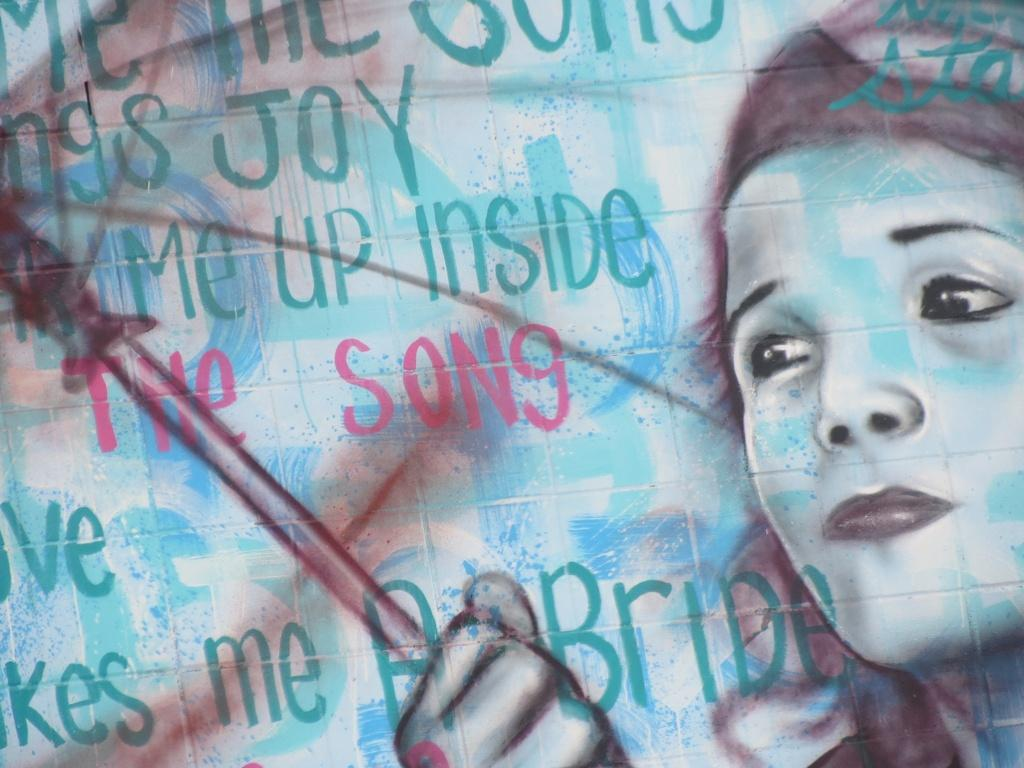What is depicted in the image? There is a sketch of a person in the image. What is the person in the sketch doing? The person is holding an object in the sketch. Where can text be found in the image? There is text on the left side of the image. What type of meat is being served by the secretary in the image? There is no secretary or meat present in the image; it features a sketch of a person holding an object. 